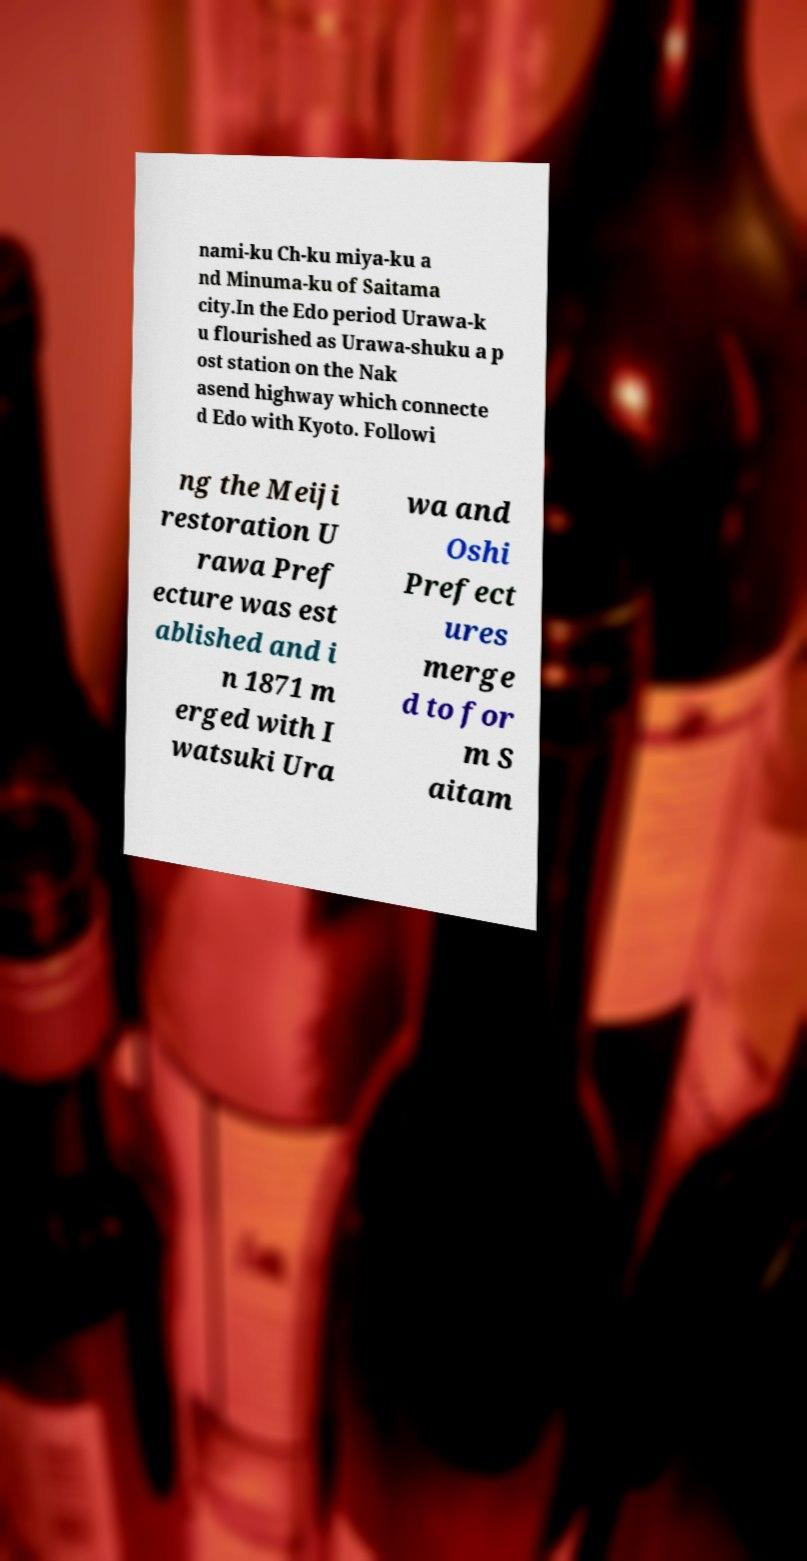There's text embedded in this image that I need extracted. Can you transcribe it verbatim? nami-ku Ch-ku miya-ku a nd Minuma-ku of Saitama city.In the Edo period Urawa-k u flourished as Urawa-shuku a p ost station on the Nak asend highway which connecte d Edo with Kyoto. Followi ng the Meiji restoration U rawa Pref ecture was est ablished and i n 1871 m erged with I watsuki Ura wa and Oshi Prefect ures merge d to for m S aitam 